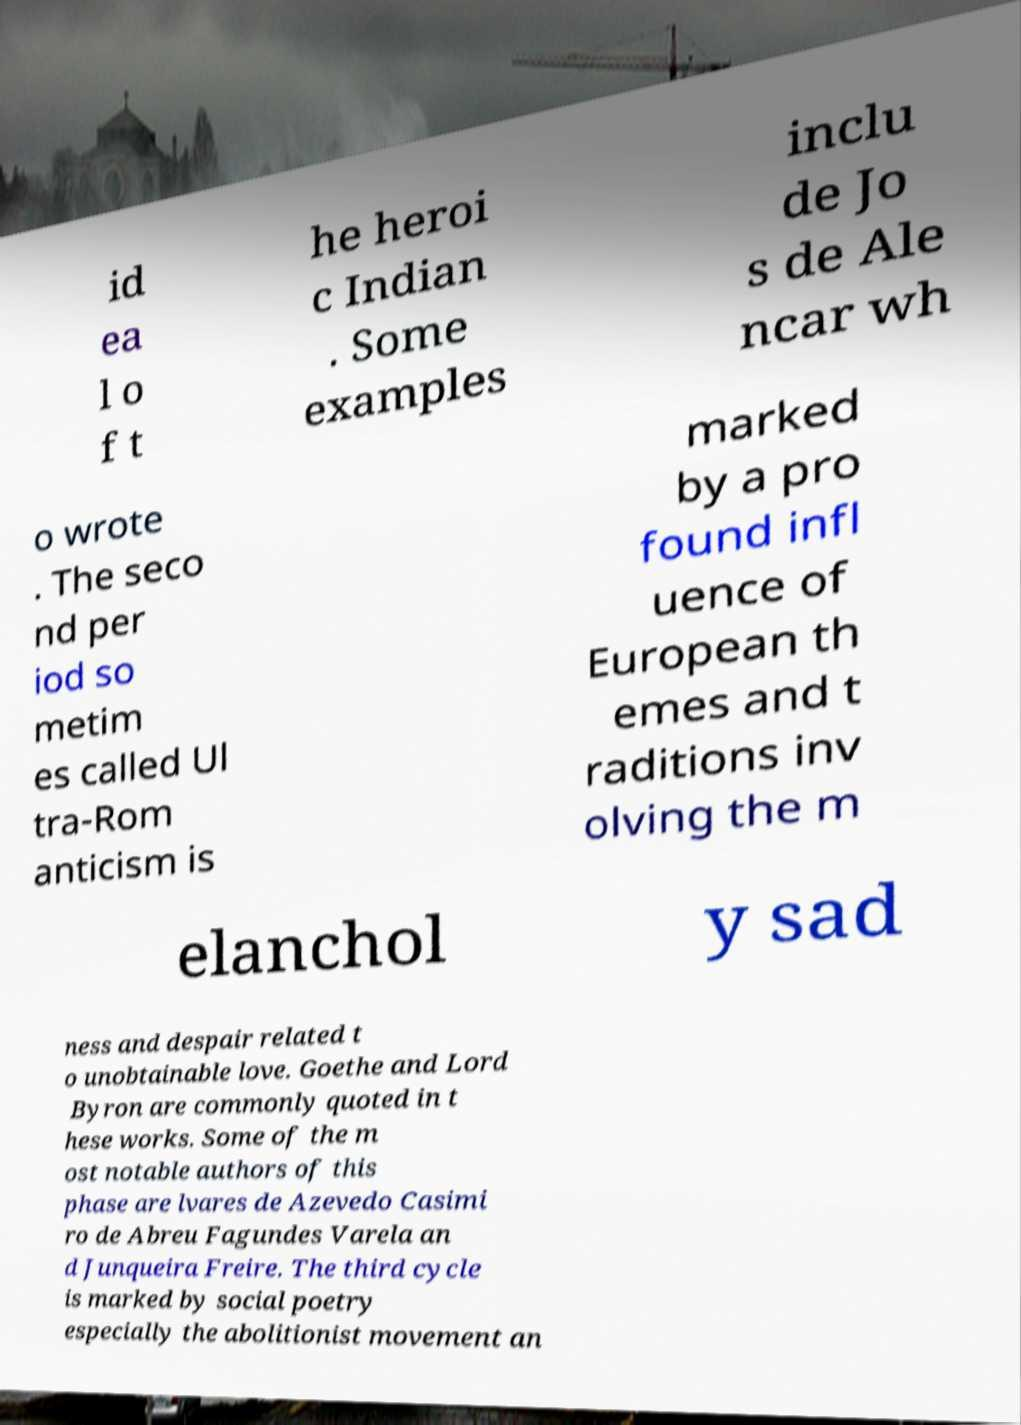Could you extract and type out the text from this image? id ea l o f t he heroi c Indian . Some examples inclu de Jo s de Ale ncar wh o wrote . The seco nd per iod so metim es called Ul tra-Rom anticism is marked by a pro found infl uence of European th emes and t raditions inv olving the m elanchol y sad ness and despair related t o unobtainable love. Goethe and Lord Byron are commonly quoted in t hese works. Some of the m ost notable authors of this phase are lvares de Azevedo Casimi ro de Abreu Fagundes Varela an d Junqueira Freire. The third cycle is marked by social poetry especially the abolitionist movement an 